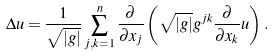Convert formula to latex. <formula><loc_0><loc_0><loc_500><loc_500>\Delta u = \frac { 1 } { \sqrt { | g | } } \sum _ { j , k = 1 } ^ { n } \frac { \partial } { \partial x _ { j } } \left ( \sqrt { | g | } g ^ { j k } \frac { \partial } { \partial x _ { k } } u \right ) .</formula> 